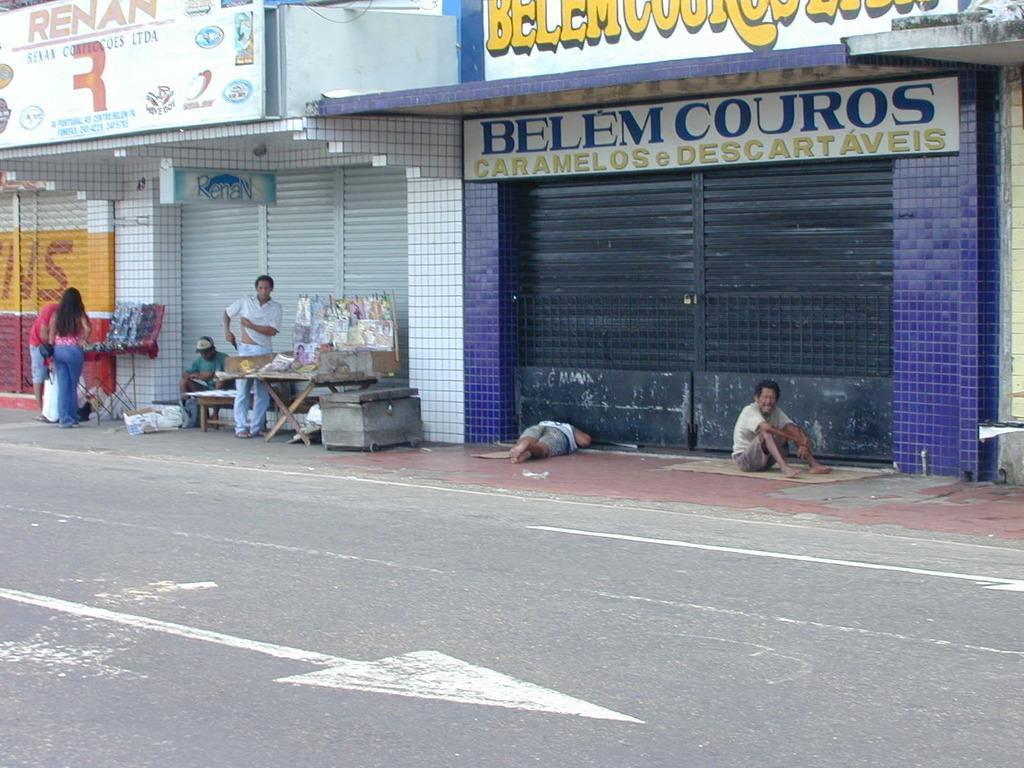How many people are in the image? There are six persons in the foreground of the image. Where are the persons located in the image? The persons are on the road, bench, table, box, and boards. What can be seen in the background of the image? There are buildings in the background of the image. When was the image taken? The image was taken during the day. What type of cloth is being used to cover the drawer in the image? There is no drawer or cloth present in the image. How many corks are visible on the table in the image? There are no corks visible on the table in the image. 